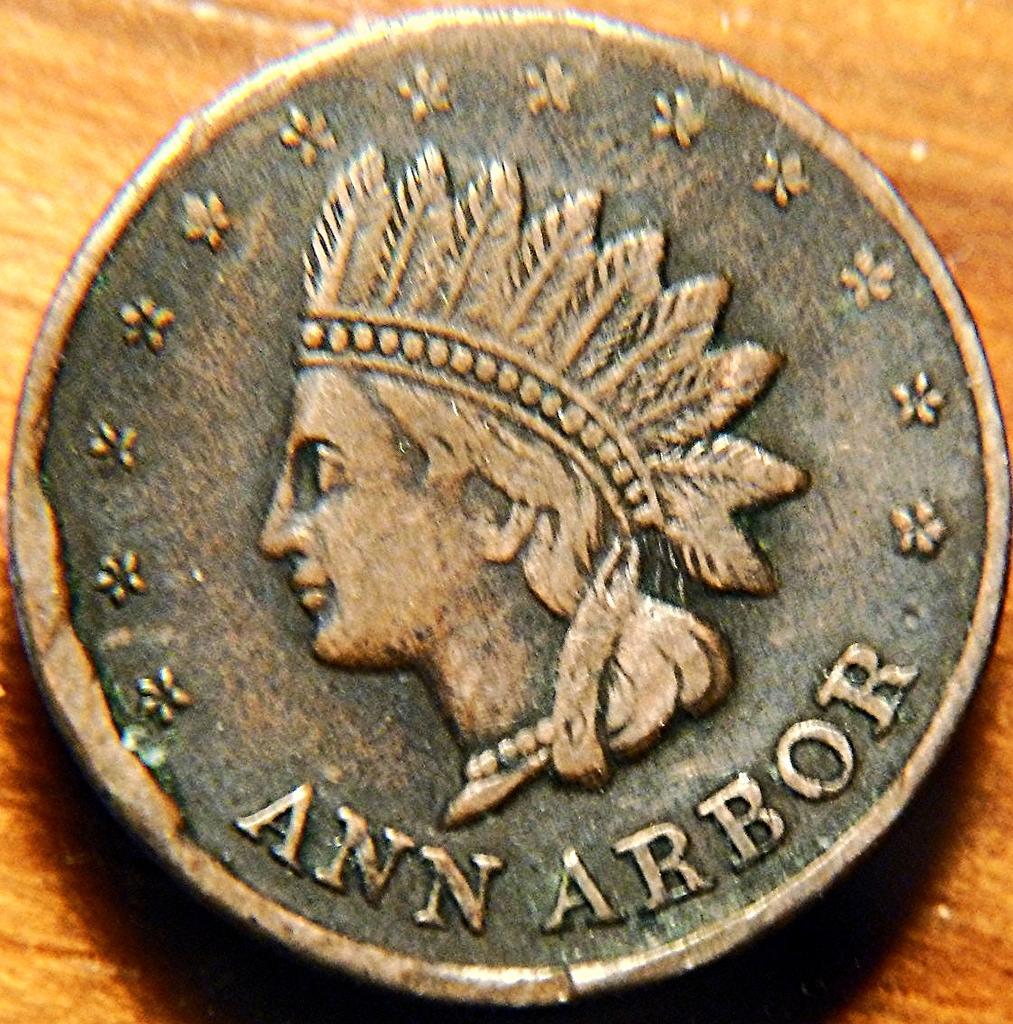Can you describe this image briefly? In the center of the image a coin is present. On coin we can see a person and some text are there. 